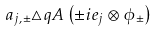<formula> <loc_0><loc_0><loc_500><loc_500>a _ { j , \pm } \triangle q A \left ( \pm i e _ { j } \otimes \phi _ { \pm } \right )</formula> 